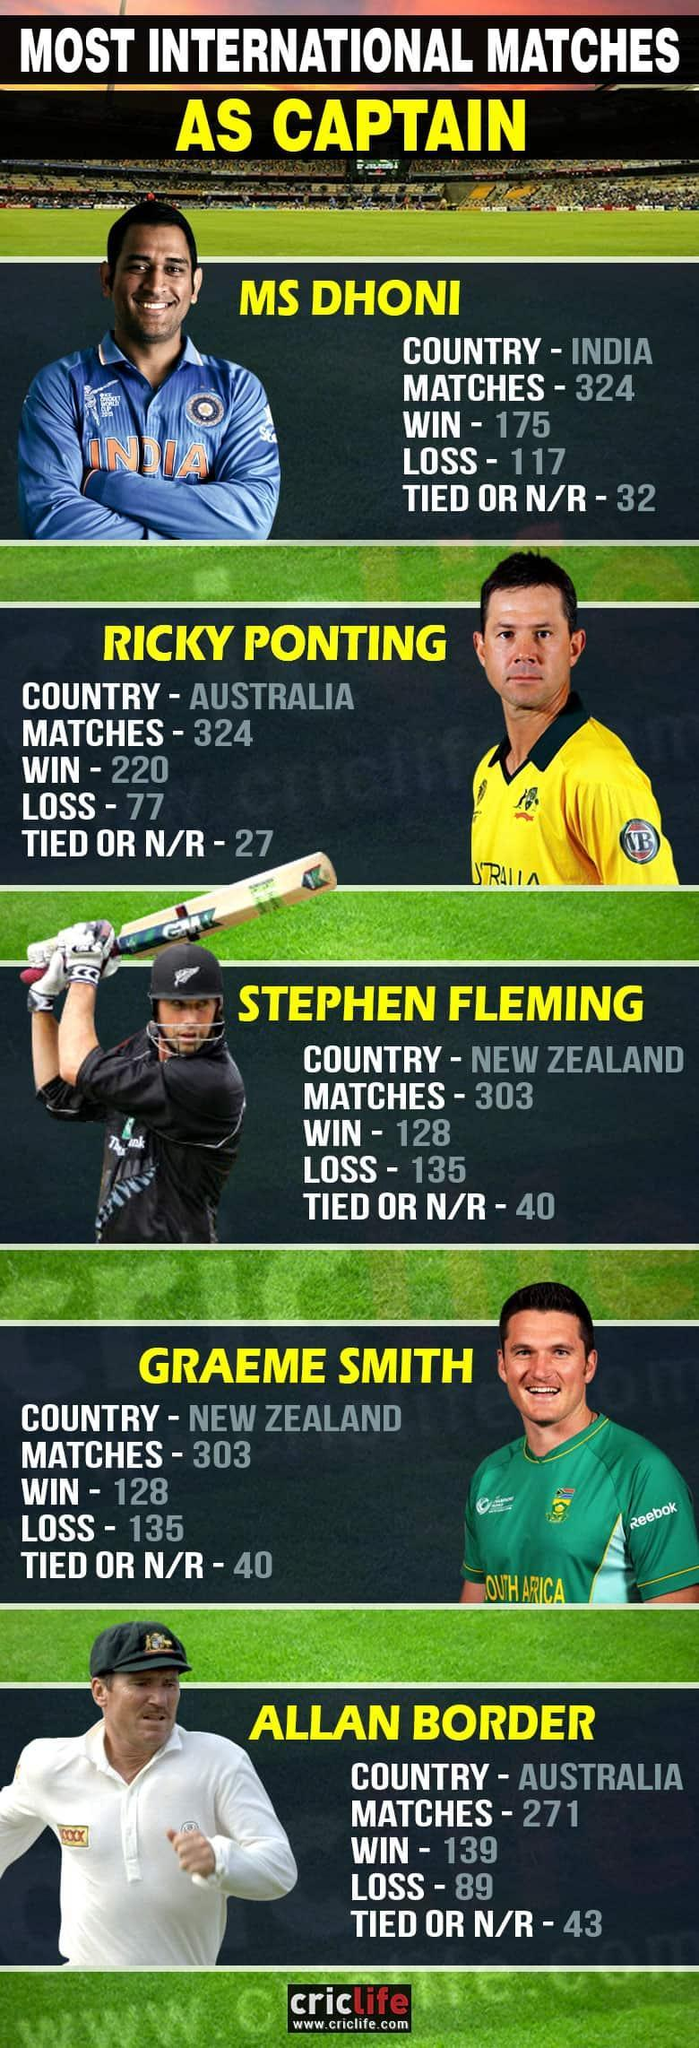Who is the successful cricket captain of all time?
Answer the question with a short phrase. Ricky Ponting What is the win percentage of MS DHONI? 54.0123 Who is the sponsor of Australia Cricket? VB What is the color of Stephen Fleming Jersey- red, black, blue, yellow? black Who is the sponsor of South Africa Cricket? Reebok What is the color of MS Dhoni Jersey- red, green, blue, yellow? blue What is the win percentage of Ricky Ponting? 67.9012 Who has lost more matches as an Australian Captain? Allan Border How many cricketers from Australia are listed? 2 